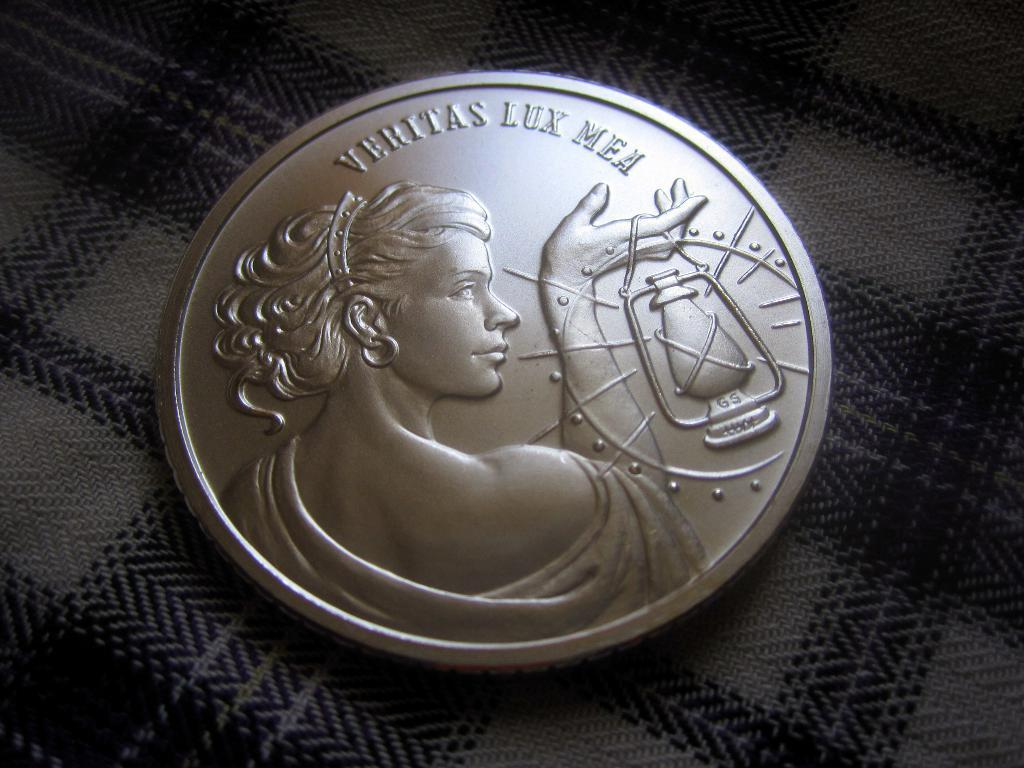<image>
Write a terse but informative summary of the picture. A coin that says "veritas lux mea" features a woman with a lantern. 